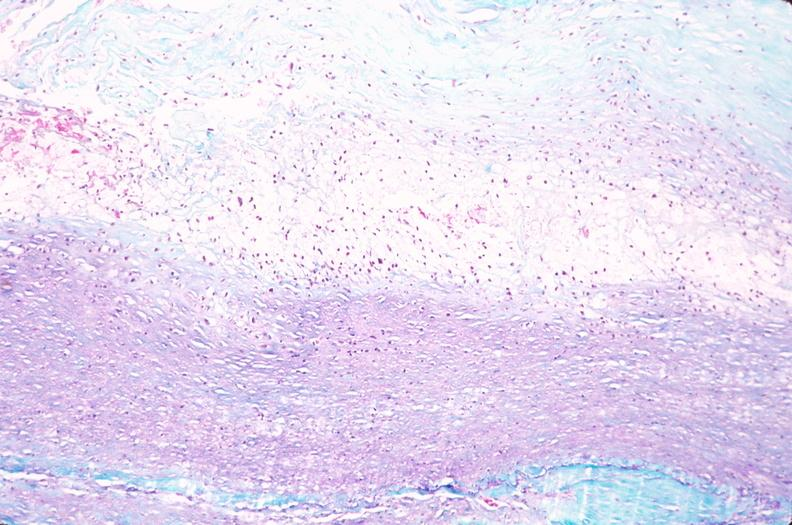s vasculature present?
Answer the question using a single word or phrase. Yes 